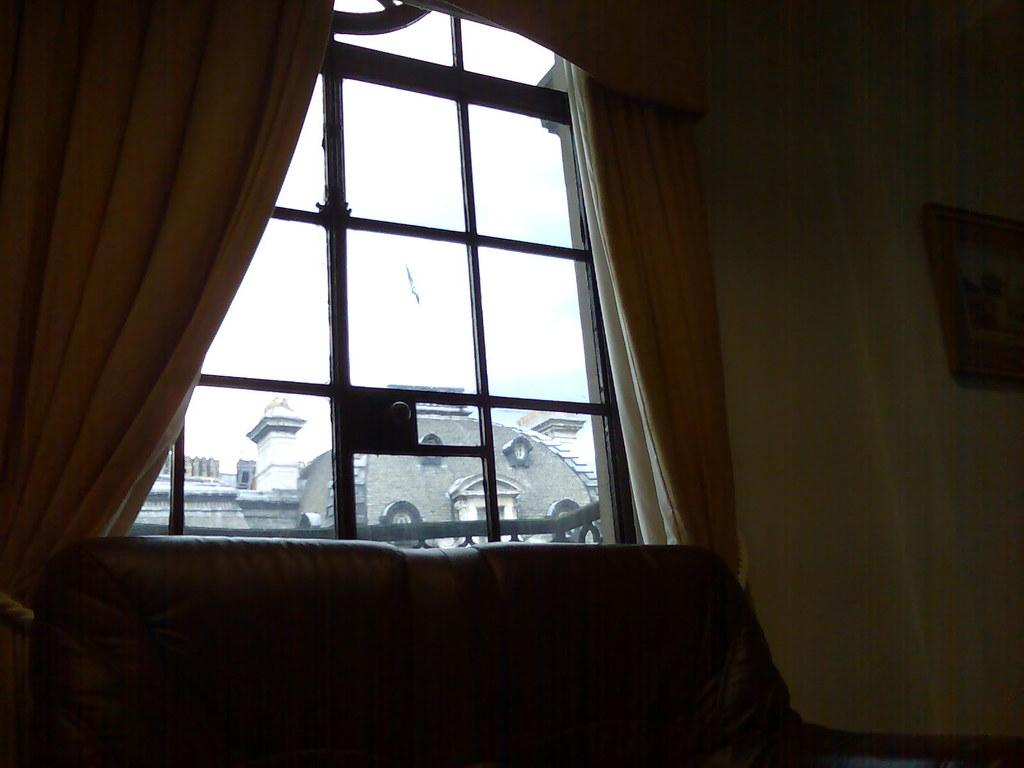What type of window treatment is present in the image? There are curtains in the image. What type of furniture is visible in the image? There is a sofa in the image. What is hanging on the wall in the image? There is a frame on the wall in the image. What can be seen in the background of the image? There is a building visible in the background of the image. Can you see a cat playing with sugar on the dock in the image? There is no cat, sugar, or dock present in the image. 